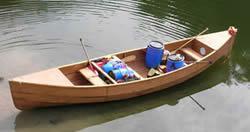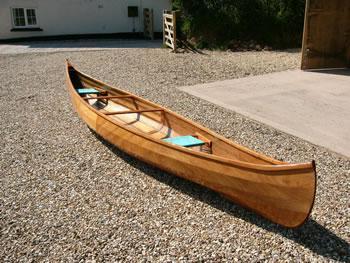The first image is the image on the left, the second image is the image on the right. Evaluate the accuracy of this statement regarding the images: "At least one boat is partially on land and partially in water.". Is it true? Answer yes or no. No. The first image is the image on the left, the second image is the image on the right. Examine the images to the left and right. Is the description "One image shows a brown canoe floating on water, and the other image shows one canoe sitting on dry ground with no water in sight." accurate? Answer yes or no. Yes. 